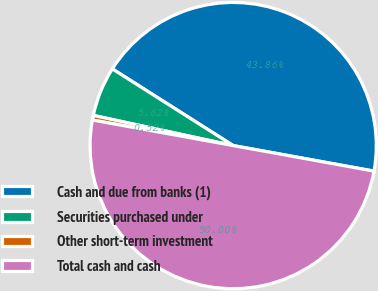Convert chart. <chart><loc_0><loc_0><loc_500><loc_500><pie_chart><fcel>Cash and due from banks (1)<fcel>Securities purchased under<fcel>Other short-term investment<fcel>Total cash and cash<nl><fcel>43.86%<fcel>5.62%<fcel>0.52%<fcel>50.0%<nl></chart> 